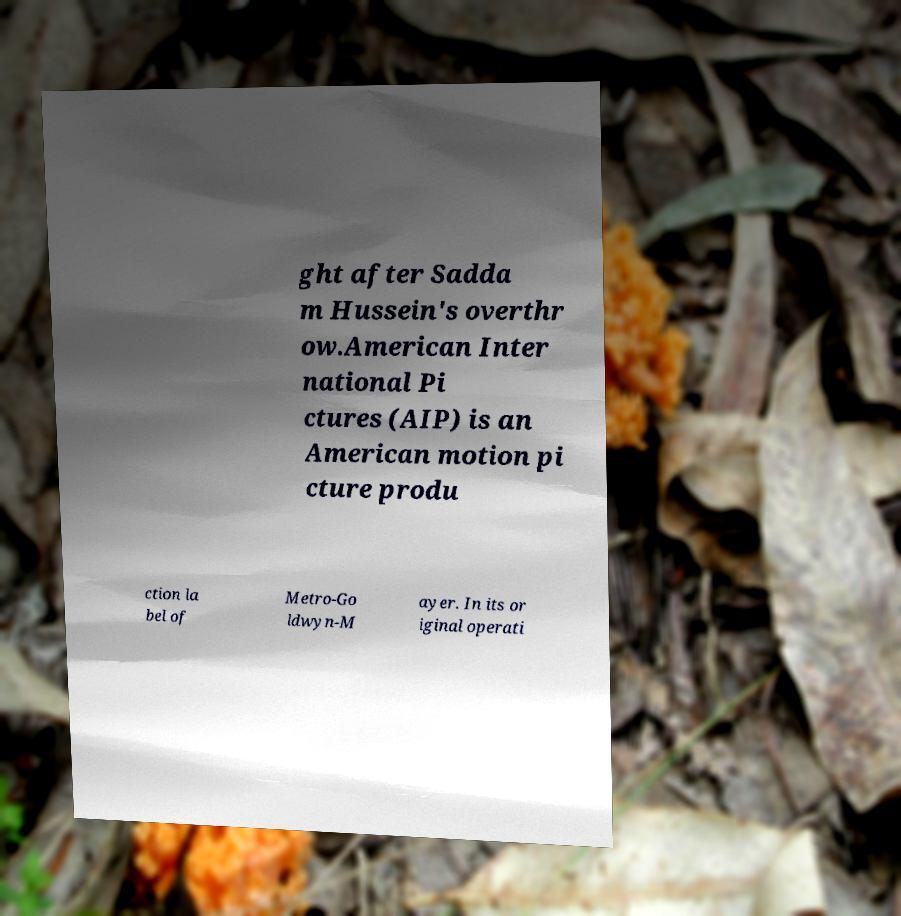Could you extract and type out the text from this image? ght after Sadda m Hussein's overthr ow.American Inter national Pi ctures (AIP) is an American motion pi cture produ ction la bel of Metro-Go ldwyn-M ayer. In its or iginal operati 